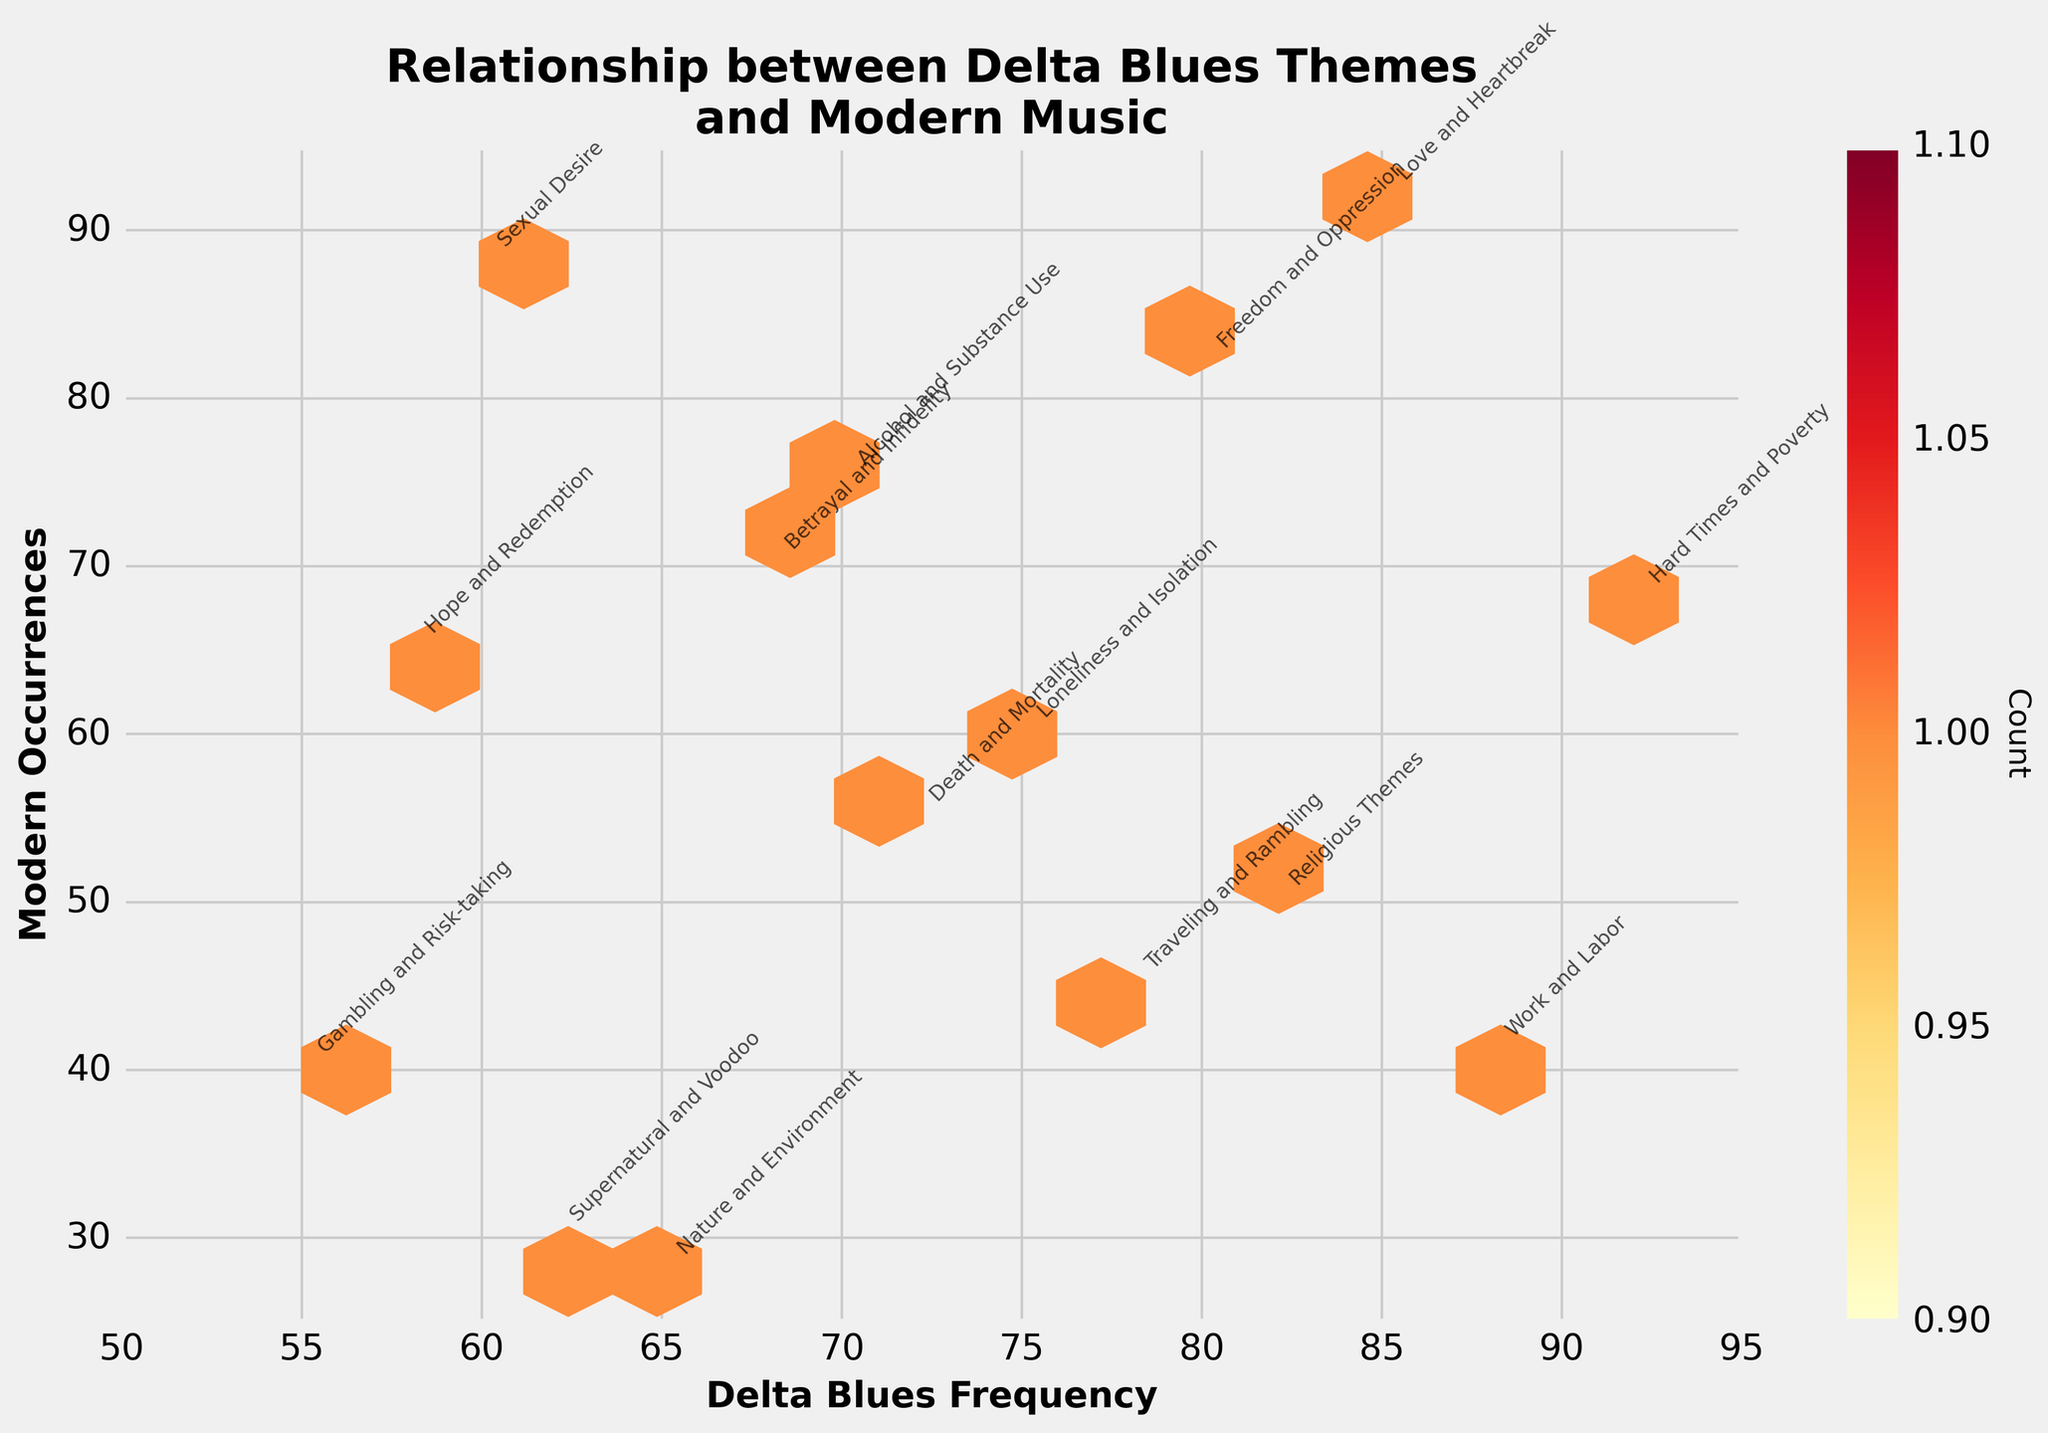What is the title of the figure? The title is the text at the top of the plot, which typically describes the entire visualization. In this case, it reads: "Relationship between Delta Blues Themes and Modern Music".
Answer: Relationship between Delta Blues Themes and Modern Music How many themes are analyzed in the plot? The annotations for the themes are visible next to the hexagons, and there are 15 unique themes mentioned.
Answer: 15 Which theme has the highest frequency in Delta Blues songs? By inspecting the x-axis and the annotations, we see that "Hard Times and Poverty" has the highest frequency at 92.
Answer: Hard Times and Poverty Which themes appear the most frequently in modern music? By examining the y-axis and annotations, the most frequent occurrence is observed for "Love and Heartbreak" and "Sexual Desire", each at 92 and 88 respectively.
Answer: Love and Heartbreak, Sexual Desire How many data points fall within the count range 2-3 in the hexbin plot? The color bar represents the count, and the color matching the range of 2-3 is observed in five specific hexagons based on the plot area.
Answer: 5 What is the combined frequency of the theme 'Work and Labor' in both Delta Blues and modern music? 'Work and Labor' frequency in Delta Blues is 88 and in modern music is 41. Adding these gives 88 + 41 = 129.
Answer: 129 Which theme has the greatest discrepancy between its frequency in Delta Blues and modern music? We calculate the absolute difference for each theme: 
Love and Heartbreak (7), Traveling and Rambling (33), 
Hard Times and Poverty (24), Supernatural and Voodoo (32), Work and Labor (47), Alcohol and Substance Use (5), Freedom and Oppression (2), 
Nature and Environment (37), Loneliness and Isolation (15), Death and Mortality (17), Betrayal and Infidelity (2), 
Hope and Redemption (7), Gambling and Risk-taking (15), Sexual Desire (28), Religious Themes (32). The largest difference is for 'Work and Labor' at 47.
Answer: Work and Labor Which two themes have the same frequency in modern music? By looking at the y-axis values of annotations, both "Love and Heartbreak" and "Freedom and Oppression" share the same frequency of 82.
Answer: Love and Heartbreak, Freedom and Oppression What is the theme with the lowest frequency in modern music? By inspecting the y-axis and the annotations, 'Nature and Environment' has the lowest frequency with a point at 28.
Answer: Nature and Environment 